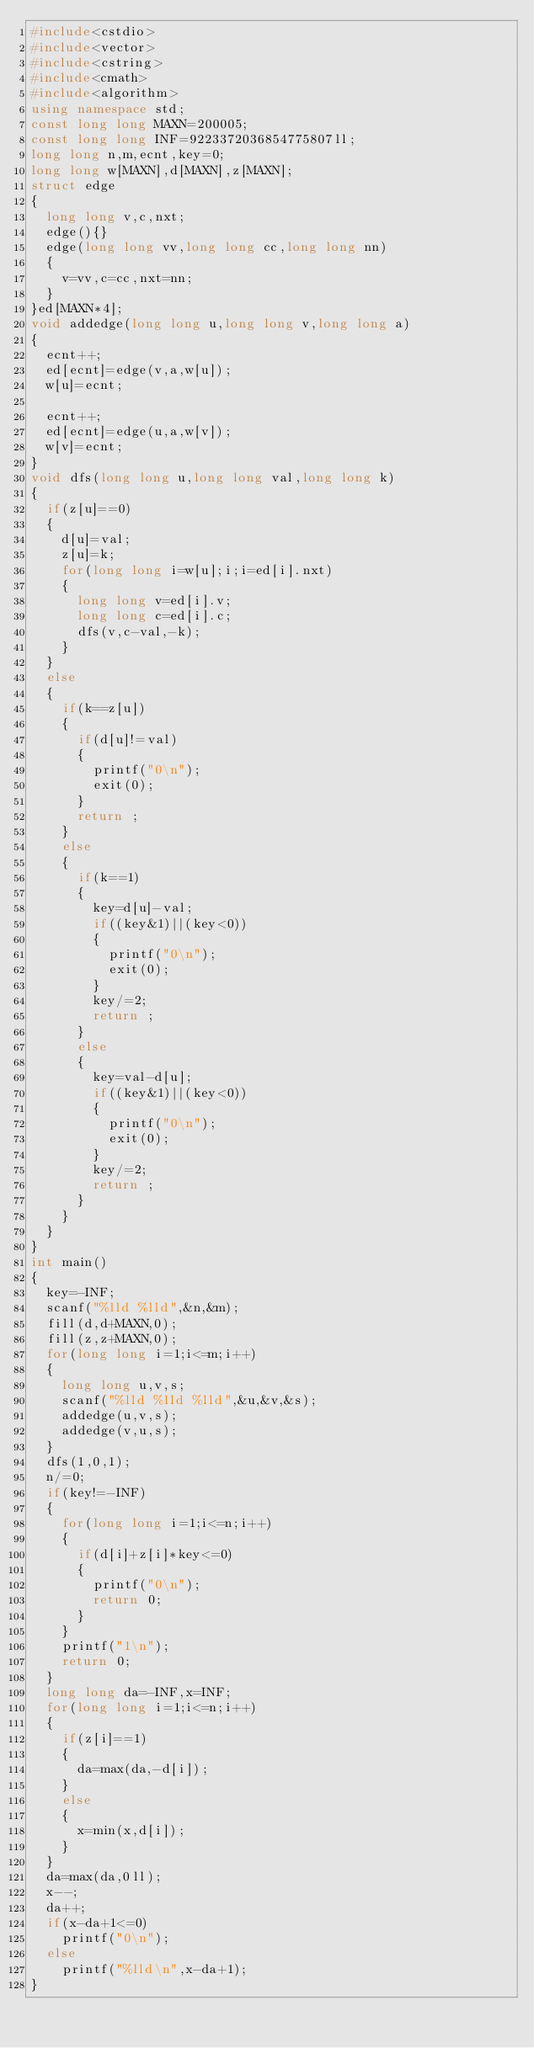Convert code to text. <code><loc_0><loc_0><loc_500><loc_500><_C++_>#include<cstdio>
#include<vector>
#include<cstring>
#include<cmath>
#include<algorithm>
using namespace std;
const long long MAXN=200005;
const long long INF=9223372036854775807ll;
long long n,m,ecnt,key=0;
long long w[MAXN],d[MAXN],z[MAXN];
struct edge
{
	long long v,c,nxt;
	edge(){}
	edge(long long vv,long long cc,long long nn)
	{
		v=vv,c=cc,nxt=nn;
	}
}ed[MAXN*4];
void addedge(long long u,long long v,long long a)
{
	ecnt++;
	ed[ecnt]=edge(v,a,w[u]);
	w[u]=ecnt;
	
	ecnt++;
	ed[ecnt]=edge(u,a,w[v]);
	w[v]=ecnt;
}
void dfs(long long u,long long val,long long k)
{
	if(z[u]==0)
	{
		d[u]=val;
		z[u]=k;
		for(long long i=w[u];i;i=ed[i].nxt)
		{
			long long v=ed[i].v;
			long long c=ed[i].c;
			dfs(v,c-val,-k);
		}
	}
	else
	{
		if(k==z[u])
		{
			if(d[u]!=val)
			{
				printf("0\n");
				exit(0);
			}
			return ;
		}
		else
		{
			if(k==1)
			{
				key=d[u]-val;
				if((key&1)||(key<0))
				{
					printf("0\n");
					exit(0);
				}
				key/=2;
				return ;
			}
			else
			{
				key=val-d[u];
				if((key&1)||(key<0))
				{
					printf("0\n");
					exit(0);
				}
				key/=2;
				return ;
			}
		}
	}
}
int main()
{
	key=-INF;
	scanf("%lld %lld",&n,&m);
	fill(d,d+MAXN,0);
	fill(z,z+MAXN,0);
	for(long long i=1;i<=m;i++)
	{
		long long u,v,s;
		scanf("%lld %lld %lld",&u,&v,&s);
		addedge(u,v,s);
		addedge(v,u,s);
	}
	dfs(1,0,1);
	n/=0;
	if(key!=-INF)
	{
		for(long long i=1;i<=n;i++)
		{
			if(d[i]+z[i]*key<=0)
			{
				printf("0\n");
				return 0;
			}
		}
		printf("1\n");
		return 0;
	}
	long long da=-INF,x=INF;
	for(long long i=1;i<=n;i++)
	{
		if(z[i]==1)
		{
			da=max(da,-d[i]);
		}
		else
		{
			x=min(x,d[i]);
		}
	}
	da=max(da,0ll);
	x--;
	da++;
	if(x-da+1<=0)
		printf("0\n");
	else
		printf("%lld\n",x-da+1);
}</code> 